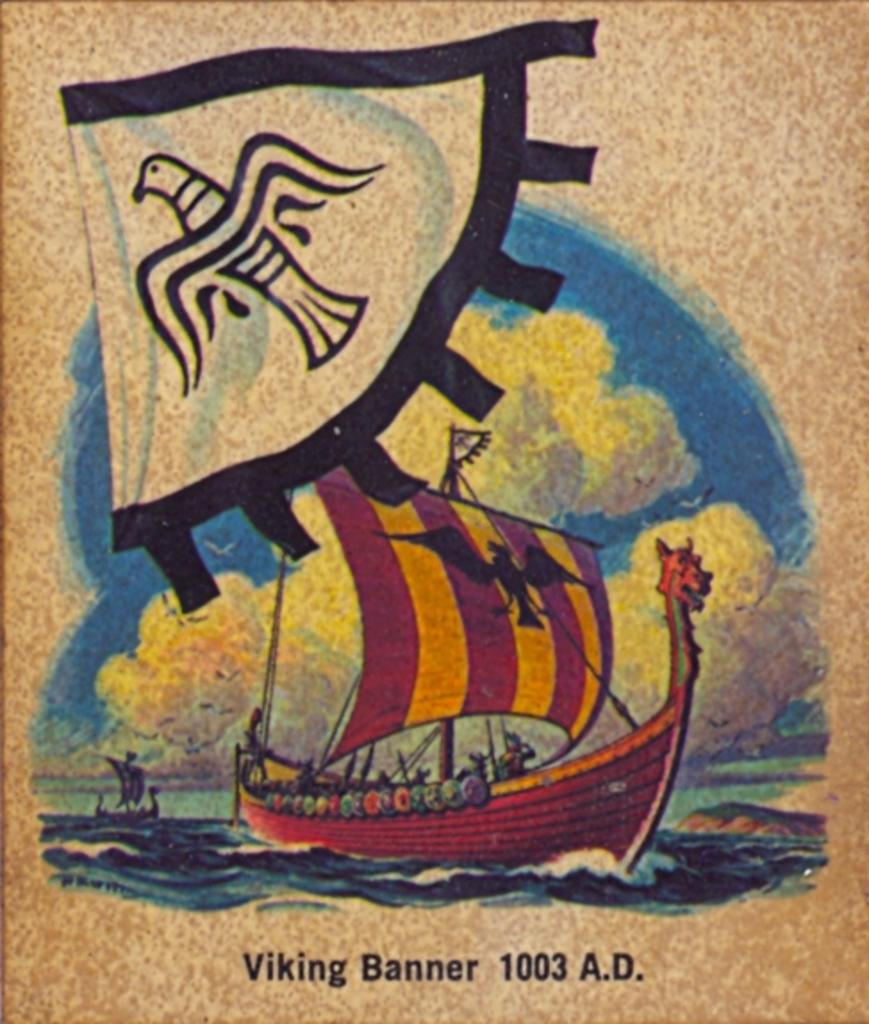Provide a one-sentence caption for the provided image. Poster showing a ship on the front and the words "Viking Banner". 